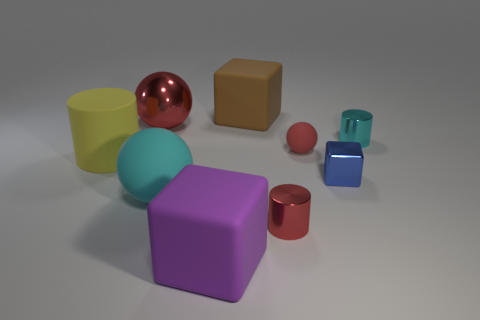Add 1 big cyan matte things. How many objects exist? 10 Subtract all balls. How many objects are left? 6 Subtract all tiny green metal cylinders. Subtract all large yellow matte objects. How many objects are left? 8 Add 6 small cyan things. How many small cyan things are left? 7 Add 2 cyan metal cubes. How many cyan metal cubes exist? 2 Subtract 0 blue cylinders. How many objects are left? 9 